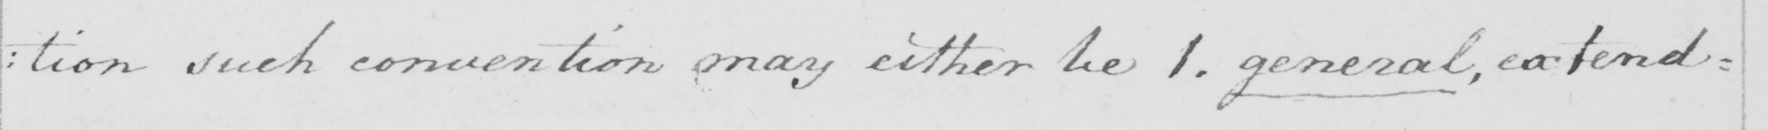What is written in this line of handwriting? : tion such convention may either be 1 . general , extend= 